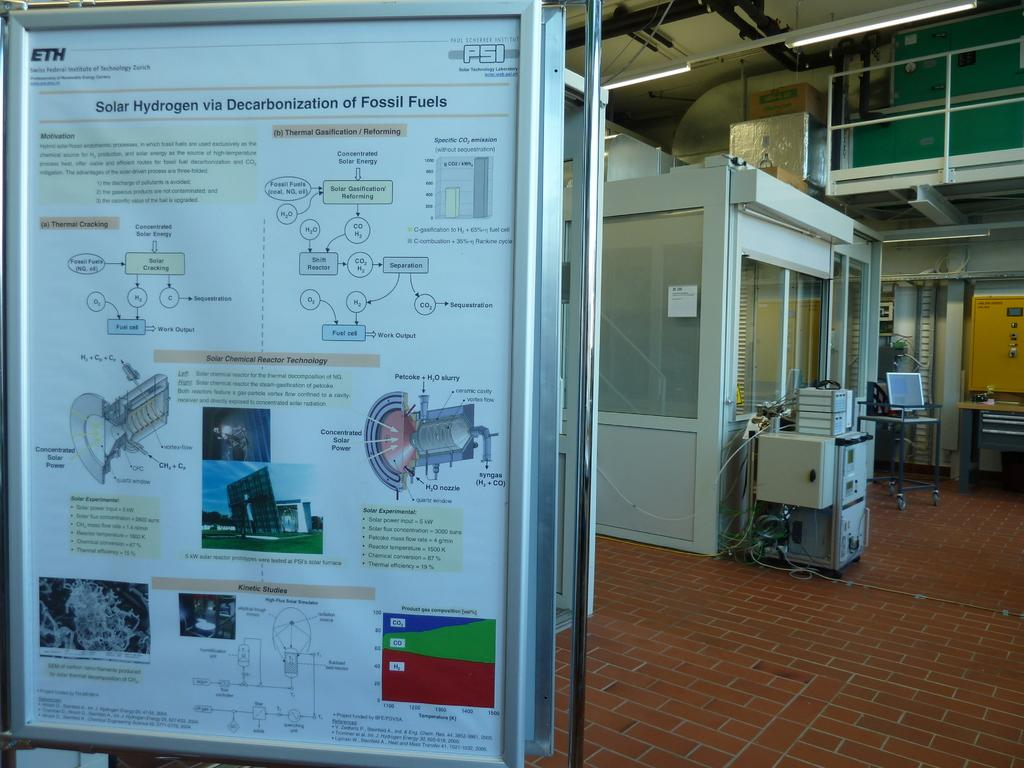<image>
Create a compact narrative representing the image presented. a large sign that says solar hydrogen on it 